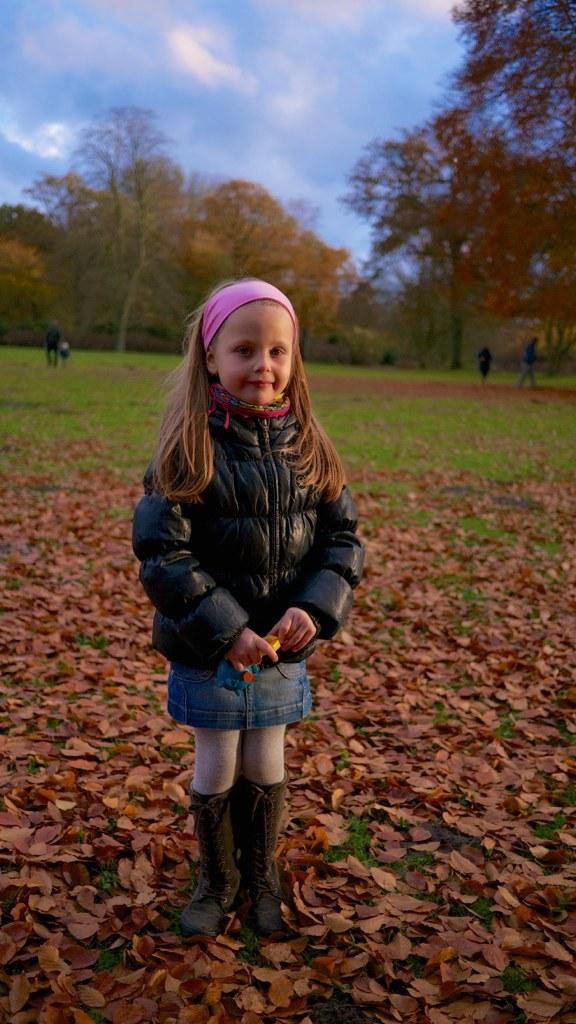Who is the main subject in the image? There is a girl in the image. What is the girl wearing? The girl is wearing a black coat. What is the girl standing on? The girl is standing on the ground with dry leaves and grass. What can be seen in the background of the image? There are trees and clouds in the blue sky in the background. What type of muscle is the girl exercising in the image? There is no indication in the image that the girl is exercising or focusing on any specific muscle. 